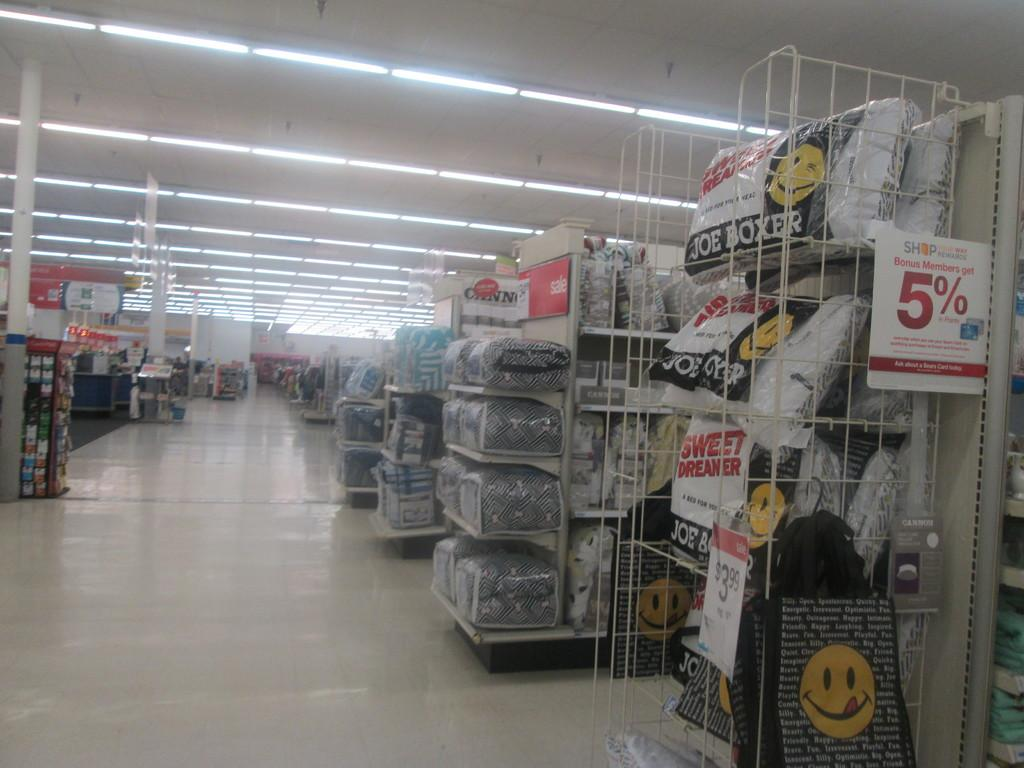What type of location is depicted in the image? The image shows the inside of a store. How are the objects arranged in the store? The objects are placed on racks and shelves in the store. What can be seen on the walls of the store? There are boards visible in the image. What helps to illuminate the store? There are lights in the image. What type of goat can be seen grazing near the store in the image? There is no goat present in the image; it depicts the inside of a store. What is the purpose of the store in the image? The purpose of the store cannot be determined from the image alone, as it only shows the interior layout and objects. 